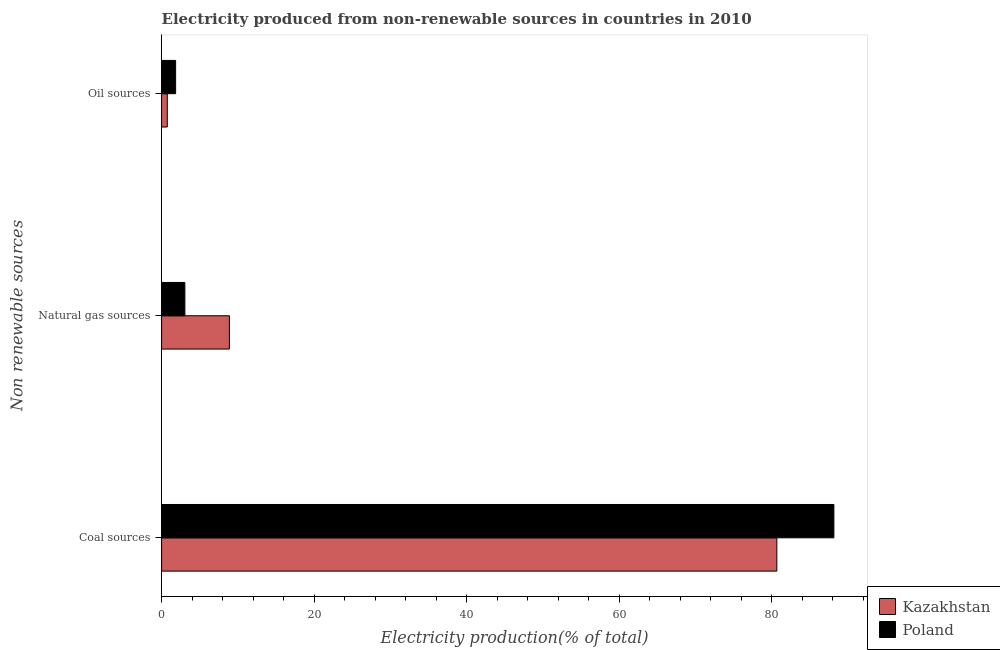Are the number of bars on each tick of the Y-axis equal?
Your response must be concise. Yes. How many bars are there on the 1st tick from the bottom?
Your answer should be very brief. 2. What is the label of the 3rd group of bars from the top?
Give a very brief answer. Coal sources. What is the percentage of electricity produced by oil sources in Poland?
Give a very brief answer. 1.84. Across all countries, what is the maximum percentage of electricity produced by coal?
Provide a succinct answer. 88.13. Across all countries, what is the minimum percentage of electricity produced by oil sources?
Your answer should be very brief. 0.75. In which country was the percentage of electricity produced by natural gas maximum?
Make the answer very short. Kazakhstan. In which country was the percentage of electricity produced by coal minimum?
Provide a succinct answer. Kazakhstan. What is the total percentage of electricity produced by oil sources in the graph?
Your answer should be very brief. 2.59. What is the difference between the percentage of electricity produced by coal in Poland and that in Kazakhstan?
Your response must be concise. 7.48. What is the difference between the percentage of electricity produced by oil sources in Poland and the percentage of electricity produced by coal in Kazakhstan?
Keep it short and to the point. -78.81. What is the average percentage of electricity produced by natural gas per country?
Your answer should be compact. 5.97. What is the difference between the percentage of electricity produced by coal and percentage of electricity produced by natural gas in Kazakhstan?
Your answer should be very brief. 71.76. In how many countries, is the percentage of electricity produced by oil sources greater than 60 %?
Your answer should be very brief. 0. What is the ratio of the percentage of electricity produced by oil sources in Kazakhstan to that in Poland?
Offer a terse response. 0.41. Is the difference between the percentage of electricity produced by coal in Poland and Kazakhstan greater than the difference between the percentage of electricity produced by oil sources in Poland and Kazakhstan?
Keep it short and to the point. Yes. What is the difference between the highest and the second highest percentage of electricity produced by natural gas?
Offer a terse response. 5.84. What is the difference between the highest and the lowest percentage of electricity produced by coal?
Ensure brevity in your answer.  7.48. Is the sum of the percentage of electricity produced by oil sources in Kazakhstan and Poland greater than the maximum percentage of electricity produced by natural gas across all countries?
Give a very brief answer. No. What does the 1st bar from the top in Oil sources represents?
Keep it short and to the point. Poland. How many countries are there in the graph?
Ensure brevity in your answer.  2. What is the difference between two consecutive major ticks on the X-axis?
Give a very brief answer. 20. Does the graph contain grids?
Offer a very short reply. No. Where does the legend appear in the graph?
Your answer should be compact. Bottom right. How many legend labels are there?
Offer a very short reply. 2. What is the title of the graph?
Make the answer very short. Electricity produced from non-renewable sources in countries in 2010. What is the label or title of the X-axis?
Provide a succinct answer. Electricity production(% of total). What is the label or title of the Y-axis?
Offer a very short reply. Non renewable sources. What is the Electricity production(% of total) in Kazakhstan in Coal sources?
Offer a terse response. 80.65. What is the Electricity production(% of total) of Poland in Coal sources?
Ensure brevity in your answer.  88.13. What is the Electricity production(% of total) in Kazakhstan in Natural gas sources?
Give a very brief answer. 8.89. What is the Electricity production(% of total) of Poland in Natural gas sources?
Your answer should be compact. 3.05. What is the Electricity production(% of total) in Kazakhstan in Oil sources?
Your answer should be compact. 0.75. What is the Electricity production(% of total) of Poland in Oil sources?
Provide a short and direct response. 1.84. Across all Non renewable sources, what is the maximum Electricity production(% of total) in Kazakhstan?
Provide a succinct answer. 80.65. Across all Non renewable sources, what is the maximum Electricity production(% of total) in Poland?
Provide a succinct answer. 88.13. Across all Non renewable sources, what is the minimum Electricity production(% of total) of Kazakhstan?
Your answer should be compact. 0.75. Across all Non renewable sources, what is the minimum Electricity production(% of total) in Poland?
Offer a very short reply. 1.84. What is the total Electricity production(% of total) of Kazakhstan in the graph?
Your answer should be very brief. 90.29. What is the total Electricity production(% of total) in Poland in the graph?
Provide a short and direct response. 93.03. What is the difference between the Electricity production(% of total) in Kazakhstan in Coal sources and that in Natural gas sources?
Your answer should be compact. 71.76. What is the difference between the Electricity production(% of total) in Poland in Coal sources and that in Natural gas sources?
Make the answer very short. 85.08. What is the difference between the Electricity production(% of total) of Kazakhstan in Coal sources and that in Oil sources?
Offer a very short reply. 79.9. What is the difference between the Electricity production(% of total) in Poland in Coal sources and that in Oil sources?
Offer a terse response. 86.29. What is the difference between the Electricity production(% of total) of Kazakhstan in Natural gas sources and that in Oil sources?
Your answer should be very brief. 8.14. What is the difference between the Electricity production(% of total) of Poland in Natural gas sources and that in Oil sources?
Provide a short and direct response. 1.21. What is the difference between the Electricity production(% of total) of Kazakhstan in Coal sources and the Electricity production(% of total) of Poland in Natural gas sources?
Give a very brief answer. 77.6. What is the difference between the Electricity production(% of total) of Kazakhstan in Coal sources and the Electricity production(% of total) of Poland in Oil sources?
Your response must be concise. 78.81. What is the difference between the Electricity production(% of total) of Kazakhstan in Natural gas sources and the Electricity production(% of total) of Poland in Oil sources?
Your answer should be very brief. 7.05. What is the average Electricity production(% of total) of Kazakhstan per Non renewable sources?
Provide a succinct answer. 30.1. What is the average Electricity production(% of total) of Poland per Non renewable sources?
Give a very brief answer. 31.01. What is the difference between the Electricity production(% of total) in Kazakhstan and Electricity production(% of total) in Poland in Coal sources?
Provide a succinct answer. -7.48. What is the difference between the Electricity production(% of total) of Kazakhstan and Electricity production(% of total) of Poland in Natural gas sources?
Your answer should be compact. 5.84. What is the difference between the Electricity production(% of total) of Kazakhstan and Electricity production(% of total) of Poland in Oil sources?
Provide a short and direct response. -1.09. What is the ratio of the Electricity production(% of total) of Kazakhstan in Coal sources to that in Natural gas sources?
Ensure brevity in your answer.  9.07. What is the ratio of the Electricity production(% of total) of Poland in Coal sources to that in Natural gas sources?
Your response must be concise. 28.85. What is the ratio of the Electricity production(% of total) in Kazakhstan in Coal sources to that in Oil sources?
Provide a short and direct response. 107.51. What is the ratio of the Electricity production(% of total) in Poland in Coal sources to that in Oil sources?
Your response must be concise. 47.87. What is the ratio of the Electricity production(% of total) in Kazakhstan in Natural gas sources to that in Oil sources?
Make the answer very short. 11.85. What is the ratio of the Electricity production(% of total) of Poland in Natural gas sources to that in Oil sources?
Keep it short and to the point. 1.66. What is the difference between the highest and the second highest Electricity production(% of total) in Kazakhstan?
Your answer should be compact. 71.76. What is the difference between the highest and the second highest Electricity production(% of total) in Poland?
Offer a very short reply. 85.08. What is the difference between the highest and the lowest Electricity production(% of total) in Kazakhstan?
Offer a very short reply. 79.9. What is the difference between the highest and the lowest Electricity production(% of total) of Poland?
Provide a short and direct response. 86.29. 